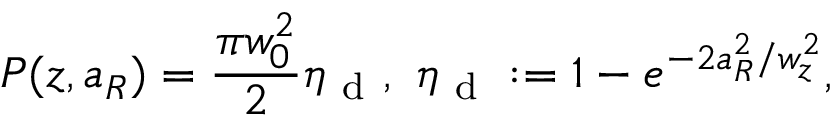<formula> <loc_0><loc_0><loc_500><loc_500>P ( z , a _ { R } ) = \frac { \pi w _ { 0 } ^ { 2 } } { 2 } \eta _ { d } , \eta _ { d } \colon = 1 - e ^ { - 2 a _ { R } ^ { 2 } / w _ { z } ^ { 2 } } ,</formula> 